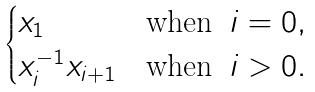<formula> <loc_0><loc_0><loc_500><loc_500>\begin{cases} x _ { 1 } & \text {when } \, i = 0 , \\ x _ { i } ^ { - 1 } x _ { i + 1 } & \text {when } \, i > 0 . \end{cases}</formula> 